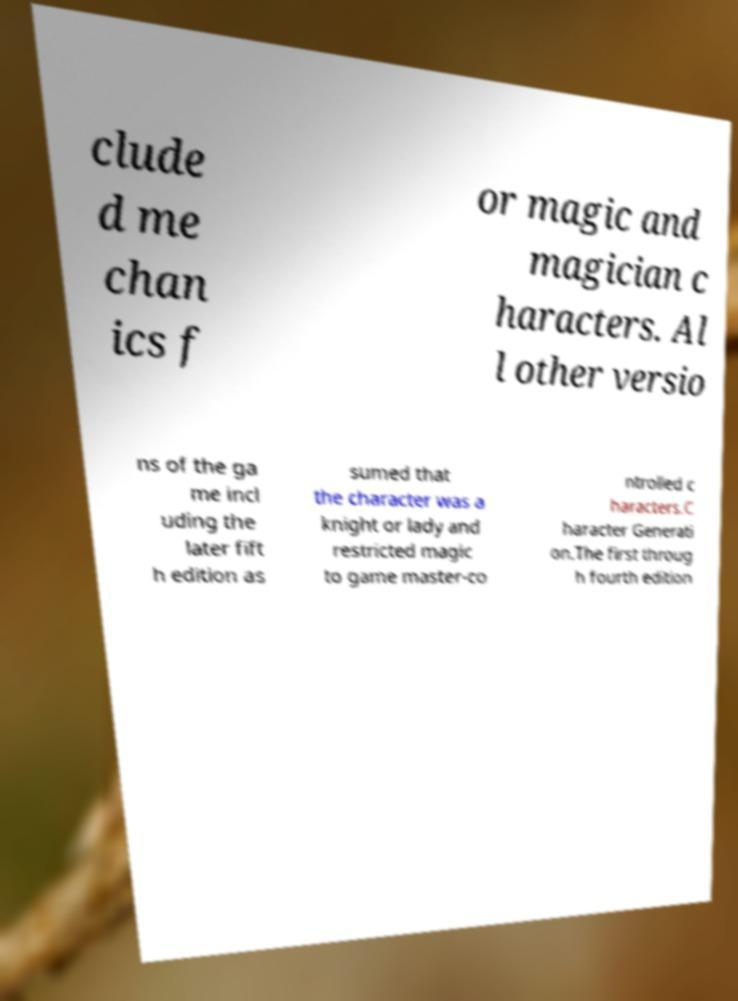Could you assist in decoding the text presented in this image and type it out clearly? clude d me chan ics f or magic and magician c haracters. Al l other versio ns of the ga me incl uding the later fift h edition as sumed that the character was a knight or lady and restricted magic to game master-co ntrolled c haracters.C haracter Generati on.The first throug h fourth edition 